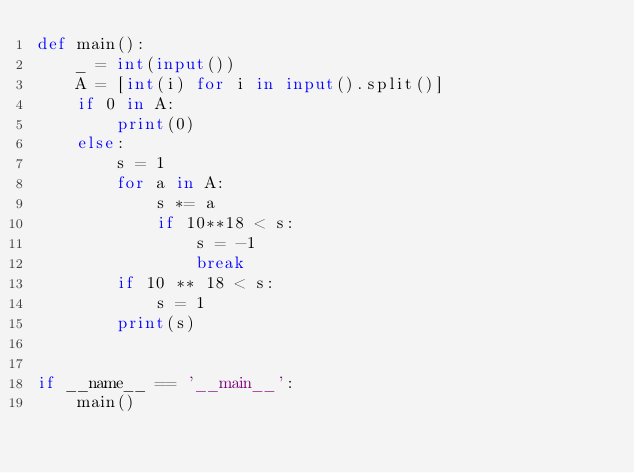<code> <loc_0><loc_0><loc_500><loc_500><_Python_>def main():
    _ = int(input())
    A = [int(i) for i in input().split()]
    if 0 in A:
        print(0)
    else:
        s = 1
        for a in A:
            s *= a
            if 10**18 < s:
                s = -1
                break
        if 10 ** 18 < s:
            s = 1
        print(s)


if __name__ == '__main__':
    main()
</code> 